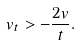Convert formula to latex. <formula><loc_0><loc_0><loc_500><loc_500>v _ { t } > - \frac { 2 v } { t } .</formula> 